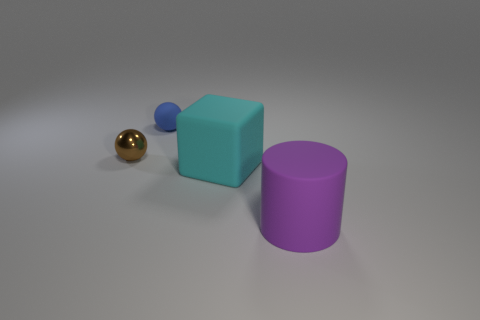What number of brown shiny objects are the same size as the blue thing?
Offer a very short reply. 1. Are there the same number of small blue balls on the left side of the tiny brown sphere and small brown objects?
Provide a short and direct response. No. What number of things are both to the left of the small blue ball and on the right side of the blue object?
Provide a succinct answer. 0. What is the size of the cyan cube that is made of the same material as the large purple cylinder?
Provide a succinct answer. Large. What number of tiny blue matte things are the same shape as the cyan thing?
Give a very brief answer. 0. Are there more blue matte spheres behind the large matte block than big purple metallic cylinders?
Your response must be concise. Yes. There is a thing that is both behind the large block and right of the brown object; what is its shape?
Give a very brief answer. Sphere. Is the shiny sphere the same size as the rubber cube?
Offer a very short reply. No. There is a big cyan cube; what number of small brown metal balls are right of it?
Make the answer very short. 0. Is the number of blue matte objects that are right of the metallic thing the same as the number of small brown metal spheres behind the cube?
Ensure brevity in your answer.  Yes. 